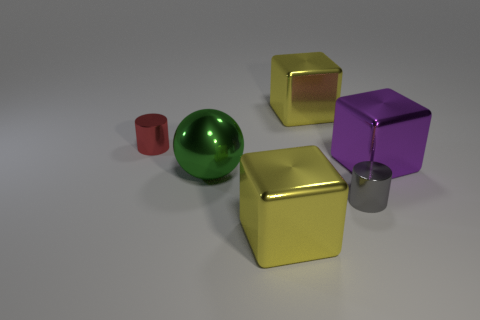What is the shape of the gray object that is made of the same material as the red cylinder? cylinder 